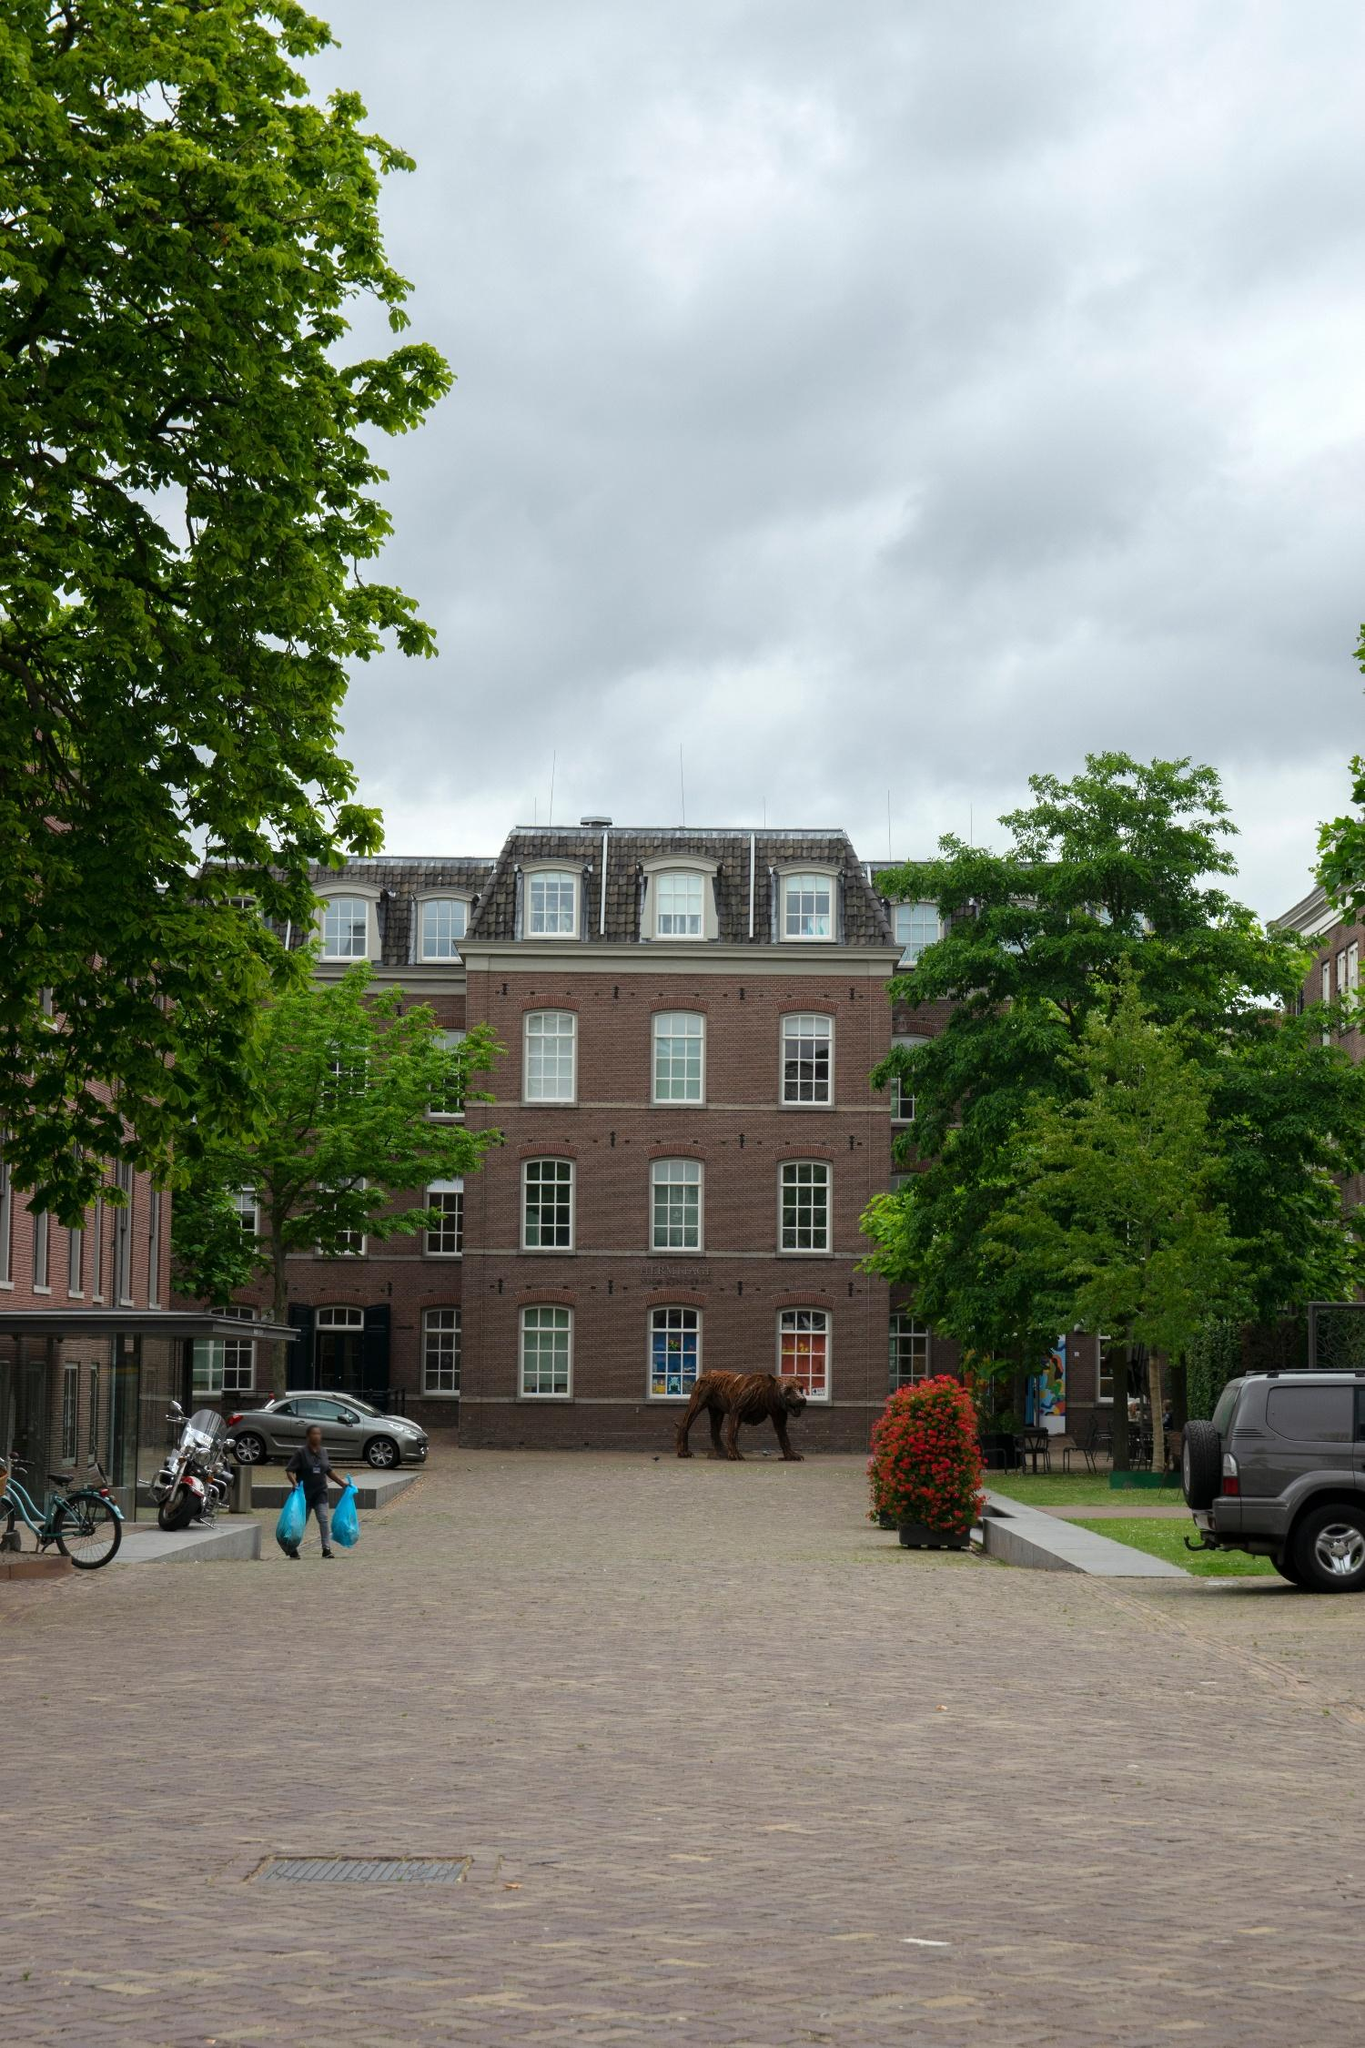If you could imagine a story for the person walking with two blue bags, what would it be? The person walking with two blue bags appears to be engaged in a daily routine. Perhaps they've just visited a local market and are carrying groceries back home. They live in one of the charming brick buildings nearby. The grey clouds overhead suggest it might rain soon, so they are hurrying back to enjoy a cozy afternoon indoors, maybe preparing a warm meal with the fresh ingredients they've just bought. 